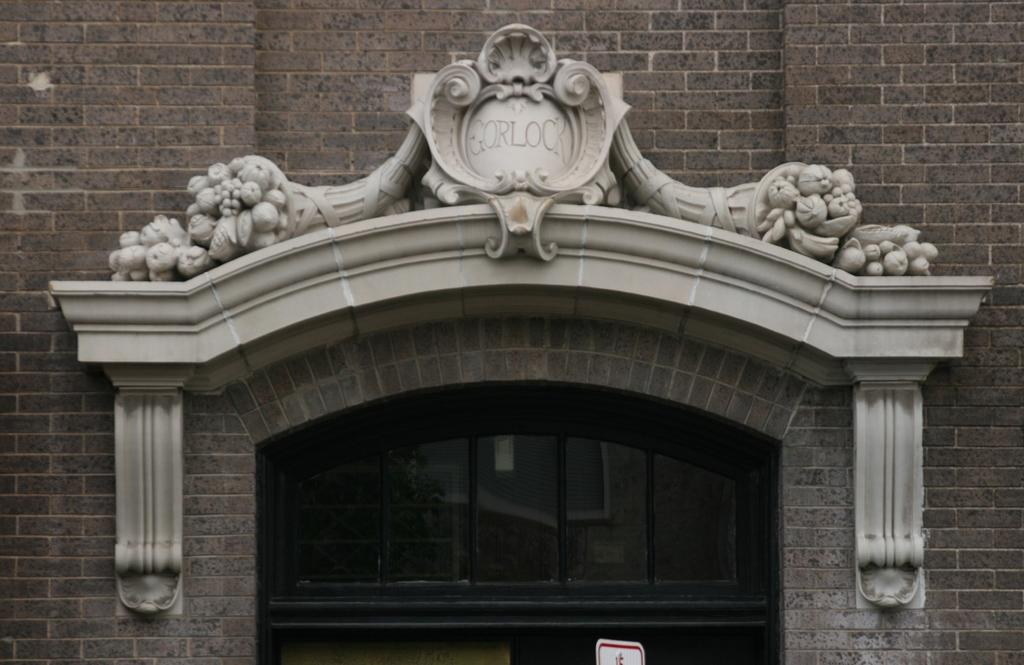What type of structure is present in the image? There is an arch in the image. What type of entrance can be seen in the image? There is a glass door in the image. What is the color of the building in the image? The building in the image is brown in color. What type of caption is written on the arch in the image? There is no caption present on the arch in the image. Can you see any bones in the image? There are no bones present in the image. 